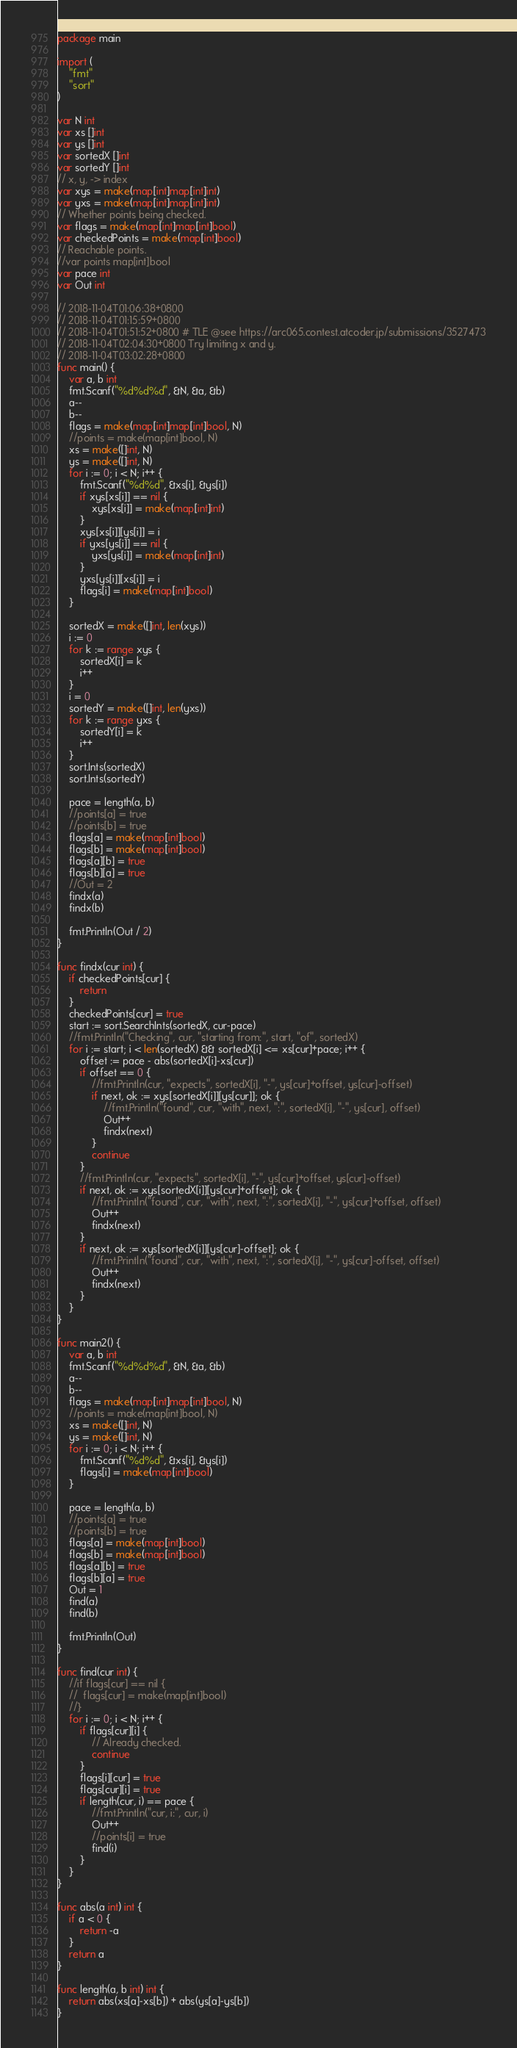Convert code to text. <code><loc_0><loc_0><loc_500><loc_500><_Go_>package main

import (
	"fmt"
	"sort"
)

var N int
var xs []int
var ys []int
var sortedX []int
var sortedY []int
// x, y, -> index
var xys = make(map[int]map[int]int)
var yxs = make(map[int]map[int]int)
// Whether points being checked.
var flags = make(map[int]map[int]bool)
var checkedPoints = make(map[int]bool)
// Reachable points.
//var points map[int]bool
var pace int
var Out int

// 2018-11-04T01:06:38+0800
// 2018-11-04T01:15:59+0800
// 2018-11-04T01:51:52+0800 # TLE @see https://arc065.contest.atcoder.jp/submissions/3527473
// 2018-11-04T02:04:30+0800 Try limiting x and y.
// 2018-11-04T03:02:28+0800
func main() {
	var a, b int
	fmt.Scanf("%d%d%d", &N, &a, &b)
	a--
	b--
	flags = make(map[int]map[int]bool, N)
	//points = make(map[int]bool, N)
	xs = make([]int, N)
	ys = make([]int, N)
	for i := 0; i < N; i++ {
		fmt.Scanf("%d%d", &xs[i], &ys[i])
		if xys[xs[i]] == nil {
			xys[xs[i]] = make(map[int]int)
		}
		xys[xs[i]][ys[i]] = i
		if yxs[ys[i]] == nil {
			yxs[ys[i]] = make(map[int]int)
		}
		yxs[ys[i]][xs[i]] = i
		flags[i] = make(map[int]bool)
	}

	sortedX = make([]int, len(xys))
	i := 0
	for k := range xys {
		sortedX[i] = k
		i++
	}
	i = 0
	sortedY = make([]int, len(yxs))
	for k := range yxs {
		sortedY[i] = k
		i++
	}
	sort.Ints(sortedX)
	sort.Ints(sortedY)

	pace = length(a, b)
	//points[a] = true
	//points[b] = true
	flags[a] = make(map[int]bool)
	flags[b] = make(map[int]bool)
	flags[a][b] = true
	flags[b][a] = true
	//Out = 2
	findx(a)
	findx(b)

	fmt.Println(Out / 2)
}

func findx(cur int) {
	if checkedPoints[cur] {
		return
	}
	checkedPoints[cur] = true
	start := sort.SearchInts(sortedX, cur-pace)
	//fmt.Println("Checking", cur, "starting from:", start, "of", sortedX)
	for i := start; i < len(sortedX) && sortedX[i] <= xs[cur]+pace; i++ {
		offset := pace - abs(sortedX[i]-xs[cur])
		if offset == 0 {
			//fmt.Println(cur, "expects", sortedX[i], "-", ys[cur]+offset, ys[cur]-offset)
			if next, ok := xys[sortedX[i]][ys[cur]]; ok {
				//fmt.Println("found", cur, "with", next, ":", sortedX[i], "-", ys[cur], offset)
				Out++
				findx(next)
			}
			continue
		}
		//fmt.Println(cur, "expects", sortedX[i], "-", ys[cur]+offset, ys[cur]-offset)
		if next, ok := xys[sortedX[i]][ys[cur]+offset]; ok {
			//fmt.Println("found", cur, "with", next, ":", sortedX[i], "-", ys[cur]+offset, offset)
			Out++
			findx(next)
		}
		if next, ok := xys[sortedX[i]][ys[cur]-offset]; ok {
			//fmt.Println("found", cur, "with", next, ":", sortedX[i], "-", ys[cur]-offset, offset)
			Out++
			findx(next)
		}
	}
}

func main2() {
	var a, b int
	fmt.Scanf("%d%d%d", &N, &a, &b)
	a--
	b--
	flags = make(map[int]map[int]bool, N)
	//points = make(map[int]bool, N)
	xs = make([]int, N)
	ys = make([]int, N)
	for i := 0; i < N; i++ {
		fmt.Scanf("%d%d", &xs[i], &ys[i])
		flags[i] = make(map[int]bool)
	}

	pace = length(a, b)
	//points[a] = true
	//points[b] = true
	flags[a] = make(map[int]bool)
	flags[b] = make(map[int]bool)
	flags[a][b] = true
	flags[b][a] = true
	Out = 1
	find(a)
	find(b)

	fmt.Println(Out)
}

func find(cur int) {
	//if flags[cur] == nil {
	//	flags[cur] = make(map[int]bool)
	//}
	for i := 0; i < N; i++ {
		if flags[cur][i] {
			// Already checked.
			continue
		}
		flags[i][cur] = true
		flags[cur][i] = true
		if length(cur, i) == pace {
			//fmt.Println("cur, i:", cur, i)
			Out++
			//points[i] = true
			find(i)
		}
	}
}

func abs(a int) int {
	if a < 0 {
		return -a
	}
	return a
}

func length(a, b int) int {
	return abs(xs[a]-xs[b]) + abs(ys[a]-ys[b])
}</code> 